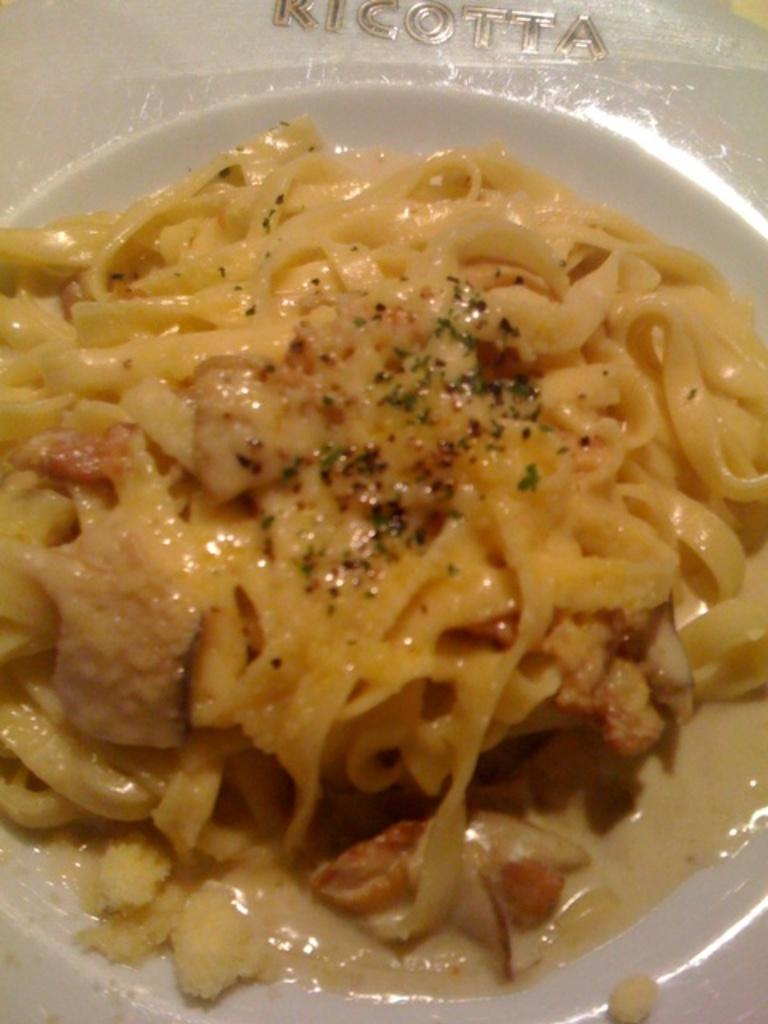What type of food is present in the image? There is food in the image, which contains pasta and cream. How is the food arranged or presented in the image? The food is in a plate. Can you see any soda in the image? There is no soda present in the image. Is there a lake visible in the image? There is no lake present in the image. 